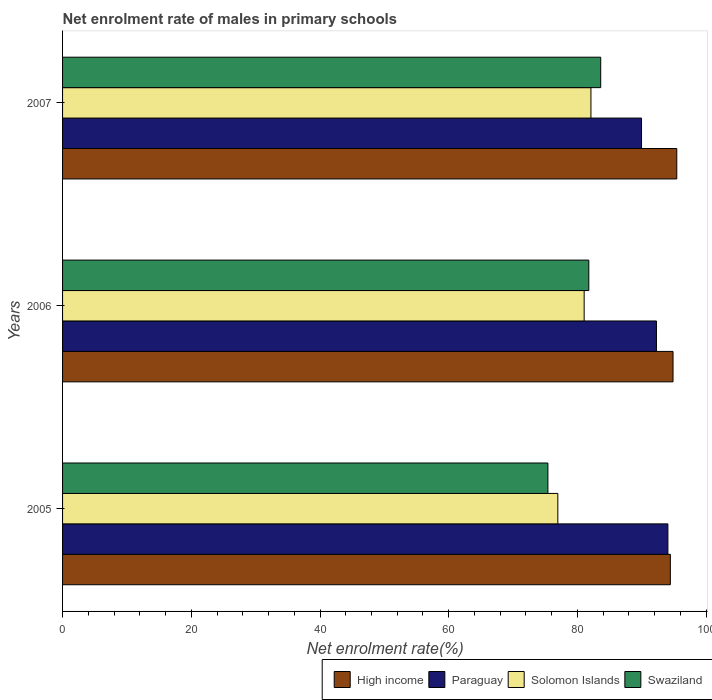How many different coloured bars are there?
Offer a very short reply. 4. Are the number of bars on each tick of the Y-axis equal?
Your answer should be compact. Yes. What is the label of the 2nd group of bars from the top?
Provide a succinct answer. 2006. In how many cases, is the number of bars for a given year not equal to the number of legend labels?
Give a very brief answer. 0. What is the net enrolment rate of males in primary schools in Swaziland in 2005?
Your response must be concise. 75.41. Across all years, what is the maximum net enrolment rate of males in primary schools in High income?
Ensure brevity in your answer.  95.43. Across all years, what is the minimum net enrolment rate of males in primary schools in Paraguay?
Keep it short and to the point. 89.96. In which year was the net enrolment rate of males in primary schools in Paraguay maximum?
Keep it short and to the point. 2005. In which year was the net enrolment rate of males in primary schools in Solomon Islands minimum?
Your response must be concise. 2005. What is the total net enrolment rate of males in primary schools in Paraguay in the graph?
Make the answer very short. 276.29. What is the difference between the net enrolment rate of males in primary schools in High income in 2005 and that in 2007?
Make the answer very short. -1. What is the difference between the net enrolment rate of males in primary schools in Solomon Islands in 2006 and the net enrolment rate of males in primary schools in High income in 2007?
Your answer should be very brief. -14.39. What is the average net enrolment rate of males in primary schools in High income per year?
Give a very brief answer. 94.91. In the year 2005, what is the difference between the net enrolment rate of males in primary schools in Swaziland and net enrolment rate of males in primary schools in Solomon Islands?
Your answer should be compact. -1.54. What is the ratio of the net enrolment rate of males in primary schools in Solomon Islands in 2006 to that in 2007?
Offer a very short reply. 0.99. What is the difference between the highest and the second highest net enrolment rate of males in primary schools in Solomon Islands?
Ensure brevity in your answer.  1.05. What is the difference between the highest and the lowest net enrolment rate of males in primary schools in Swaziland?
Offer a very short reply. 8.21. In how many years, is the net enrolment rate of males in primary schools in Swaziland greater than the average net enrolment rate of males in primary schools in Swaziland taken over all years?
Offer a very short reply. 2. What does the 4th bar from the top in 2005 represents?
Give a very brief answer. High income. How many years are there in the graph?
Offer a terse response. 3. Where does the legend appear in the graph?
Keep it short and to the point. Bottom right. How many legend labels are there?
Provide a short and direct response. 4. How are the legend labels stacked?
Give a very brief answer. Horizontal. What is the title of the graph?
Offer a terse response. Net enrolment rate of males in primary schools. What is the label or title of the X-axis?
Ensure brevity in your answer.  Net enrolment rate(%). What is the Net enrolment rate(%) of High income in 2005?
Your answer should be compact. 94.43. What is the Net enrolment rate(%) in Paraguay in 2005?
Your response must be concise. 94.05. What is the Net enrolment rate(%) of Solomon Islands in 2005?
Provide a succinct answer. 76.95. What is the Net enrolment rate(%) in Swaziland in 2005?
Your response must be concise. 75.41. What is the Net enrolment rate(%) of High income in 2006?
Ensure brevity in your answer.  94.85. What is the Net enrolment rate(%) of Paraguay in 2006?
Ensure brevity in your answer.  92.28. What is the Net enrolment rate(%) of Solomon Islands in 2006?
Offer a terse response. 81.04. What is the Net enrolment rate(%) of Swaziland in 2006?
Provide a short and direct response. 81.77. What is the Net enrolment rate(%) in High income in 2007?
Offer a terse response. 95.43. What is the Net enrolment rate(%) in Paraguay in 2007?
Your answer should be compact. 89.96. What is the Net enrolment rate(%) of Solomon Islands in 2007?
Your answer should be very brief. 82.1. What is the Net enrolment rate(%) of Swaziland in 2007?
Give a very brief answer. 83.62. Across all years, what is the maximum Net enrolment rate(%) of High income?
Your answer should be very brief. 95.43. Across all years, what is the maximum Net enrolment rate(%) in Paraguay?
Provide a succinct answer. 94.05. Across all years, what is the maximum Net enrolment rate(%) of Solomon Islands?
Give a very brief answer. 82.1. Across all years, what is the maximum Net enrolment rate(%) in Swaziland?
Your answer should be compact. 83.62. Across all years, what is the minimum Net enrolment rate(%) of High income?
Ensure brevity in your answer.  94.43. Across all years, what is the minimum Net enrolment rate(%) of Paraguay?
Provide a short and direct response. 89.96. Across all years, what is the minimum Net enrolment rate(%) in Solomon Islands?
Provide a short and direct response. 76.95. Across all years, what is the minimum Net enrolment rate(%) of Swaziland?
Ensure brevity in your answer.  75.41. What is the total Net enrolment rate(%) of High income in the graph?
Your answer should be very brief. 284.72. What is the total Net enrolment rate(%) in Paraguay in the graph?
Provide a short and direct response. 276.29. What is the total Net enrolment rate(%) of Solomon Islands in the graph?
Give a very brief answer. 240.09. What is the total Net enrolment rate(%) of Swaziland in the graph?
Provide a succinct answer. 240.79. What is the difference between the Net enrolment rate(%) of High income in 2005 and that in 2006?
Provide a succinct answer. -0.42. What is the difference between the Net enrolment rate(%) of Paraguay in 2005 and that in 2006?
Keep it short and to the point. 1.78. What is the difference between the Net enrolment rate(%) of Solomon Islands in 2005 and that in 2006?
Provide a succinct answer. -4.09. What is the difference between the Net enrolment rate(%) of Swaziland in 2005 and that in 2006?
Offer a terse response. -6.36. What is the difference between the Net enrolment rate(%) in High income in 2005 and that in 2007?
Your answer should be very brief. -1. What is the difference between the Net enrolment rate(%) of Paraguay in 2005 and that in 2007?
Your response must be concise. 4.1. What is the difference between the Net enrolment rate(%) of Solomon Islands in 2005 and that in 2007?
Make the answer very short. -5.14. What is the difference between the Net enrolment rate(%) in Swaziland in 2005 and that in 2007?
Offer a terse response. -8.21. What is the difference between the Net enrolment rate(%) of High income in 2006 and that in 2007?
Keep it short and to the point. -0.58. What is the difference between the Net enrolment rate(%) in Paraguay in 2006 and that in 2007?
Your answer should be compact. 2.32. What is the difference between the Net enrolment rate(%) in Solomon Islands in 2006 and that in 2007?
Your answer should be very brief. -1.05. What is the difference between the Net enrolment rate(%) in Swaziland in 2006 and that in 2007?
Ensure brevity in your answer.  -1.85. What is the difference between the Net enrolment rate(%) of High income in 2005 and the Net enrolment rate(%) of Paraguay in 2006?
Provide a succinct answer. 2.16. What is the difference between the Net enrolment rate(%) of High income in 2005 and the Net enrolment rate(%) of Solomon Islands in 2006?
Provide a short and direct response. 13.39. What is the difference between the Net enrolment rate(%) in High income in 2005 and the Net enrolment rate(%) in Swaziland in 2006?
Ensure brevity in your answer.  12.67. What is the difference between the Net enrolment rate(%) in Paraguay in 2005 and the Net enrolment rate(%) in Solomon Islands in 2006?
Ensure brevity in your answer.  13.01. What is the difference between the Net enrolment rate(%) of Paraguay in 2005 and the Net enrolment rate(%) of Swaziland in 2006?
Give a very brief answer. 12.29. What is the difference between the Net enrolment rate(%) of Solomon Islands in 2005 and the Net enrolment rate(%) of Swaziland in 2006?
Your response must be concise. -4.81. What is the difference between the Net enrolment rate(%) of High income in 2005 and the Net enrolment rate(%) of Paraguay in 2007?
Your response must be concise. 4.47. What is the difference between the Net enrolment rate(%) in High income in 2005 and the Net enrolment rate(%) in Solomon Islands in 2007?
Keep it short and to the point. 12.34. What is the difference between the Net enrolment rate(%) in High income in 2005 and the Net enrolment rate(%) in Swaziland in 2007?
Provide a succinct answer. 10.82. What is the difference between the Net enrolment rate(%) in Paraguay in 2005 and the Net enrolment rate(%) in Solomon Islands in 2007?
Your answer should be very brief. 11.96. What is the difference between the Net enrolment rate(%) in Paraguay in 2005 and the Net enrolment rate(%) in Swaziland in 2007?
Offer a terse response. 10.44. What is the difference between the Net enrolment rate(%) in Solomon Islands in 2005 and the Net enrolment rate(%) in Swaziland in 2007?
Ensure brevity in your answer.  -6.66. What is the difference between the Net enrolment rate(%) of High income in 2006 and the Net enrolment rate(%) of Paraguay in 2007?
Your response must be concise. 4.89. What is the difference between the Net enrolment rate(%) of High income in 2006 and the Net enrolment rate(%) of Solomon Islands in 2007?
Provide a succinct answer. 12.75. What is the difference between the Net enrolment rate(%) of High income in 2006 and the Net enrolment rate(%) of Swaziland in 2007?
Offer a very short reply. 11.23. What is the difference between the Net enrolment rate(%) in Paraguay in 2006 and the Net enrolment rate(%) in Solomon Islands in 2007?
Your answer should be very brief. 10.18. What is the difference between the Net enrolment rate(%) in Paraguay in 2006 and the Net enrolment rate(%) in Swaziland in 2007?
Your answer should be very brief. 8.66. What is the difference between the Net enrolment rate(%) in Solomon Islands in 2006 and the Net enrolment rate(%) in Swaziland in 2007?
Provide a short and direct response. -2.57. What is the average Net enrolment rate(%) in High income per year?
Your answer should be compact. 94.91. What is the average Net enrolment rate(%) of Paraguay per year?
Your answer should be very brief. 92.1. What is the average Net enrolment rate(%) in Solomon Islands per year?
Your answer should be compact. 80.03. What is the average Net enrolment rate(%) in Swaziland per year?
Provide a succinct answer. 80.26. In the year 2005, what is the difference between the Net enrolment rate(%) of High income and Net enrolment rate(%) of Paraguay?
Give a very brief answer. 0.38. In the year 2005, what is the difference between the Net enrolment rate(%) in High income and Net enrolment rate(%) in Solomon Islands?
Offer a very short reply. 17.48. In the year 2005, what is the difference between the Net enrolment rate(%) of High income and Net enrolment rate(%) of Swaziland?
Make the answer very short. 19.02. In the year 2005, what is the difference between the Net enrolment rate(%) of Paraguay and Net enrolment rate(%) of Solomon Islands?
Keep it short and to the point. 17.1. In the year 2005, what is the difference between the Net enrolment rate(%) in Paraguay and Net enrolment rate(%) in Swaziland?
Offer a very short reply. 18.65. In the year 2005, what is the difference between the Net enrolment rate(%) in Solomon Islands and Net enrolment rate(%) in Swaziland?
Ensure brevity in your answer.  1.54. In the year 2006, what is the difference between the Net enrolment rate(%) in High income and Net enrolment rate(%) in Paraguay?
Give a very brief answer. 2.58. In the year 2006, what is the difference between the Net enrolment rate(%) of High income and Net enrolment rate(%) of Solomon Islands?
Provide a short and direct response. 13.81. In the year 2006, what is the difference between the Net enrolment rate(%) in High income and Net enrolment rate(%) in Swaziland?
Your response must be concise. 13.08. In the year 2006, what is the difference between the Net enrolment rate(%) in Paraguay and Net enrolment rate(%) in Solomon Islands?
Make the answer very short. 11.23. In the year 2006, what is the difference between the Net enrolment rate(%) in Paraguay and Net enrolment rate(%) in Swaziland?
Offer a terse response. 10.51. In the year 2006, what is the difference between the Net enrolment rate(%) in Solomon Islands and Net enrolment rate(%) in Swaziland?
Your answer should be compact. -0.72. In the year 2007, what is the difference between the Net enrolment rate(%) of High income and Net enrolment rate(%) of Paraguay?
Offer a very short reply. 5.48. In the year 2007, what is the difference between the Net enrolment rate(%) in High income and Net enrolment rate(%) in Solomon Islands?
Your answer should be very brief. 13.34. In the year 2007, what is the difference between the Net enrolment rate(%) in High income and Net enrolment rate(%) in Swaziland?
Provide a succinct answer. 11.82. In the year 2007, what is the difference between the Net enrolment rate(%) of Paraguay and Net enrolment rate(%) of Solomon Islands?
Your answer should be compact. 7.86. In the year 2007, what is the difference between the Net enrolment rate(%) in Paraguay and Net enrolment rate(%) in Swaziland?
Ensure brevity in your answer.  6.34. In the year 2007, what is the difference between the Net enrolment rate(%) in Solomon Islands and Net enrolment rate(%) in Swaziland?
Keep it short and to the point. -1.52. What is the ratio of the Net enrolment rate(%) in Paraguay in 2005 to that in 2006?
Provide a short and direct response. 1.02. What is the ratio of the Net enrolment rate(%) of Solomon Islands in 2005 to that in 2006?
Your answer should be compact. 0.95. What is the ratio of the Net enrolment rate(%) of Swaziland in 2005 to that in 2006?
Your answer should be compact. 0.92. What is the ratio of the Net enrolment rate(%) in High income in 2005 to that in 2007?
Give a very brief answer. 0.99. What is the ratio of the Net enrolment rate(%) of Paraguay in 2005 to that in 2007?
Ensure brevity in your answer.  1.05. What is the ratio of the Net enrolment rate(%) of Solomon Islands in 2005 to that in 2007?
Your answer should be very brief. 0.94. What is the ratio of the Net enrolment rate(%) in Swaziland in 2005 to that in 2007?
Provide a short and direct response. 0.9. What is the ratio of the Net enrolment rate(%) in Paraguay in 2006 to that in 2007?
Offer a terse response. 1.03. What is the ratio of the Net enrolment rate(%) of Solomon Islands in 2006 to that in 2007?
Keep it short and to the point. 0.99. What is the ratio of the Net enrolment rate(%) in Swaziland in 2006 to that in 2007?
Your answer should be compact. 0.98. What is the difference between the highest and the second highest Net enrolment rate(%) of High income?
Your response must be concise. 0.58. What is the difference between the highest and the second highest Net enrolment rate(%) of Paraguay?
Keep it short and to the point. 1.78. What is the difference between the highest and the second highest Net enrolment rate(%) in Solomon Islands?
Ensure brevity in your answer.  1.05. What is the difference between the highest and the second highest Net enrolment rate(%) of Swaziland?
Your answer should be very brief. 1.85. What is the difference between the highest and the lowest Net enrolment rate(%) in Paraguay?
Offer a terse response. 4.1. What is the difference between the highest and the lowest Net enrolment rate(%) of Solomon Islands?
Offer a terse response. 5.14. What is the difference between the highest and the lowest Net enrolment rate(%) in Swaziland?
Provide a succinct answer. 8.21. 